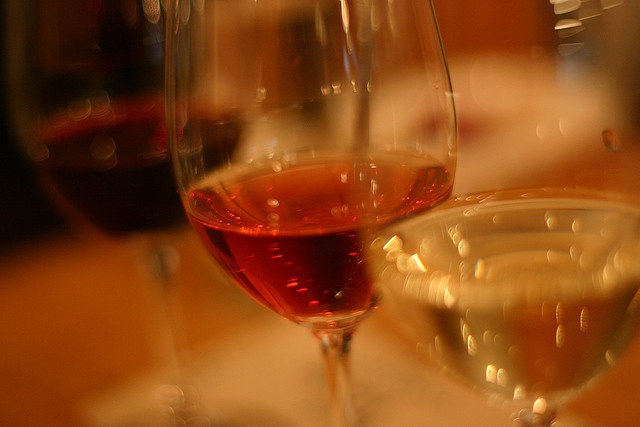Describe the objects in this image and their specific colors. I can see wine glass in black, brown, and maroon tones, wine glass in black, red, maroon, and orange tones, and wine glass in black, red, maroon, and orange tones in this image. 